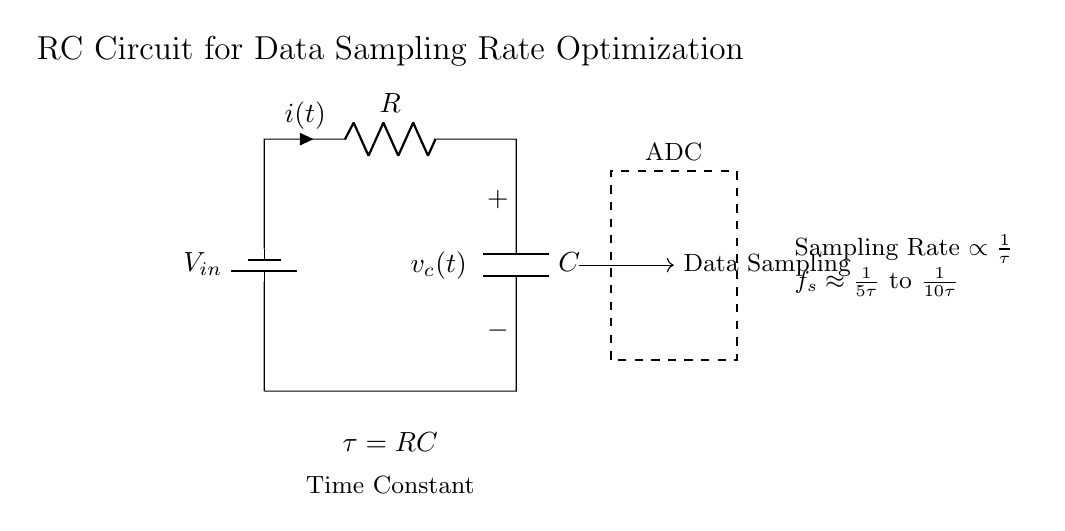What is the role of the battery in this circuit? The battery supplies the input voltage, which is essential for powering the circuit. It creates a potential difference that drives the current through the resistor and capacitor.
Answer: Supply voltage What does the resistor represent in this circuit? The resistor regulates the current flow and contributes to the time constant of the RC circuit. It has a value denoted as R in ohms and affects how quickly the capacitor charges or discharges.
Answer: Resistor value What happens when the time constant increases? An increase in the time constant means the capacitor charges or discharges more slowly, leading to a lower sampling rate, as higher time constants result in longer intervals for signal capture.
Answer: Lower sampling rate What does the time constant formula indicate? The formula τ = RC indicates that the time constant (tau) is the product of resistance and capacitance, highlighting how both components influence the circuit's response time.
Answer: τ = RC What is the approximate sampling rate range shown? The sampling rate range is shown as being proportional to 1 over the time constant, specifically between one-fifth and one-tenth of the time constant, indicating a relationship between time constant and sampling frequency.
Answer: One-fifth to one-tenth of tau What does the dashed rectangle in the diagram represent? The dashed rectangle denotes the ADC (Analog to Digital Converter), which is involved in capturing and digitizing the sampled signal from the capacitor for further processing or analysis.
Answer: ADC What effect does reducing resistance have on the circuit behavior? Reducing the resistance decreases the time constant, causing the capacitor to charge or discharge faster, which could result in a higher sampling rate as the circuit can respond more quickly to changes.
Answer: Faster circuit response 